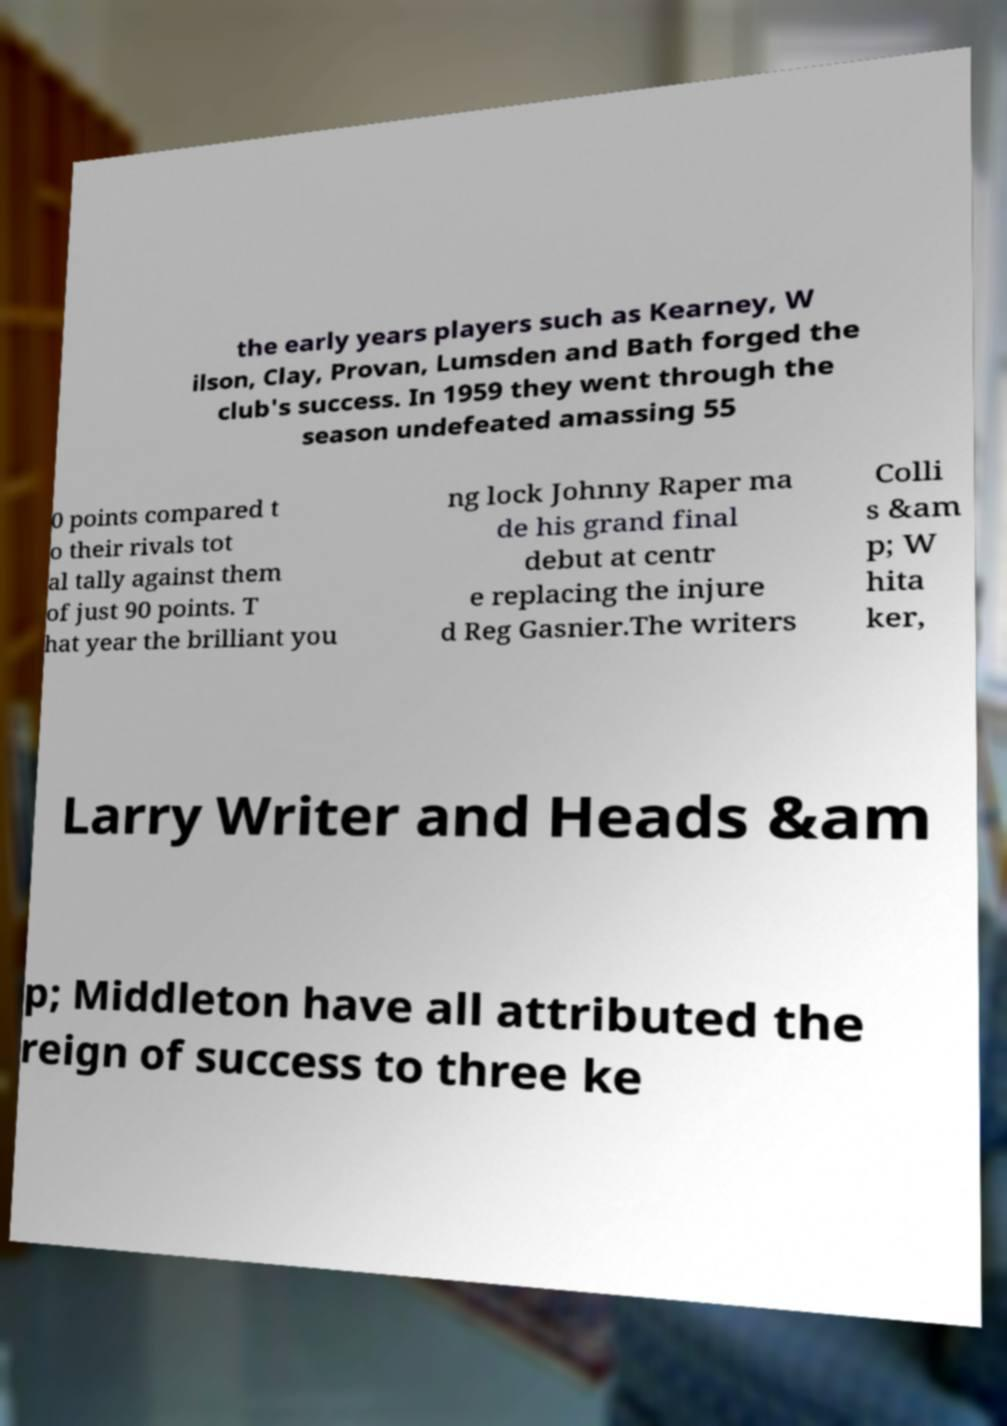Can you read and provide the text displayed in the image?This photo seems to have some interesting text. Can you extract and type it out for me? the early years players such as Kearney, W ilson, Clay, Provan, Lumsden and Bath forged the club's success. In 1959 they went through the season undefeated amassing 55 0 points compared t o their rivals tot al tally against them of just 90 points. T hat year the brilliant you ng lock Johnny Raper ma de his grand final debut at centr e replacing the injure d Reg Gasnier.The writers Colli s &am p; W hita ker, Larry Writer and Heads &am p; Middleton have all attributed the reign of success to three ke 